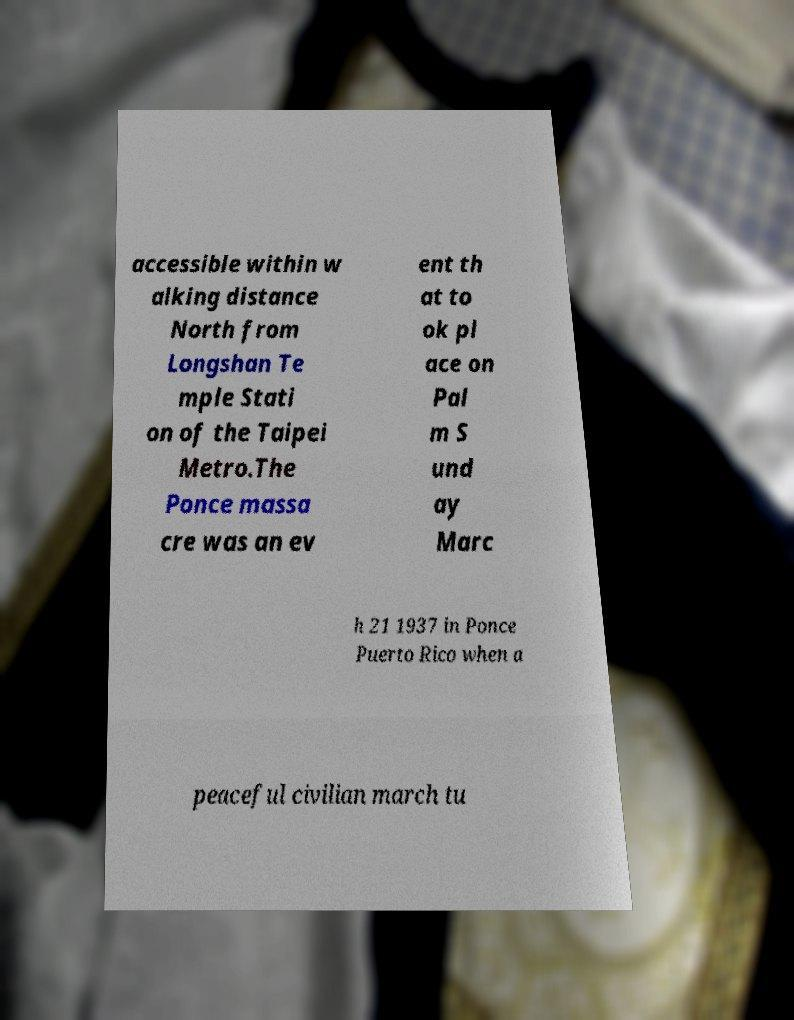There's text embedded in this image that I need extracted. Can you transcribe it verbatim? accessible within w alking distance North from Longshan Te mple Stati on of the Taipei Metro.The Ponce massa cre was an ev ent th at to ok pl ace on Pal m S und ay Marc h 21 1937 in Ponce Puerto Rico when a peaceful civilian march tu 